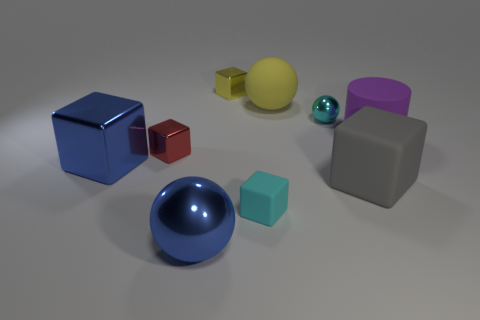What number of balls are both in front of the red object and behind the cyan matte cube?
Keep it short and to the point. 0. There is a cyan sphere that is the same size as the cyan rubber thing; what is it made of?
Offer a terse response. Metal. Do the metallic sphere that is in front of the large rubber cylinder and the cyan thing that is on the left side of the cyan shiny thing have the same size?
Provide a short and direct response. No. There is a purple cylinder; are there any small balls in front of it?
Provide a succinct answer. No. There is a tiny thing that is on the left side of the ball that is in front of the large purple rubber cylinder; what is its color?
Offer a very short reply. Red. Is the number of small yellow metal objects less than the number of large red objects?
Make the answer very short. No. What number of other small yellow things have the same shape as the small rubber object?
Your response must be concise. 1. The rubber sphere that is the same size as the cylinder is what color?
Offer a terse response. Yellow. Are there an equal number of rubber cubes that are on the left side of the cyan metallic object and gray blocks to the left of the tiny red object?
Offer a terse response. No. Is there a red cube that has the same size as the purple rubber object?
Your answer should be very brief. No. 